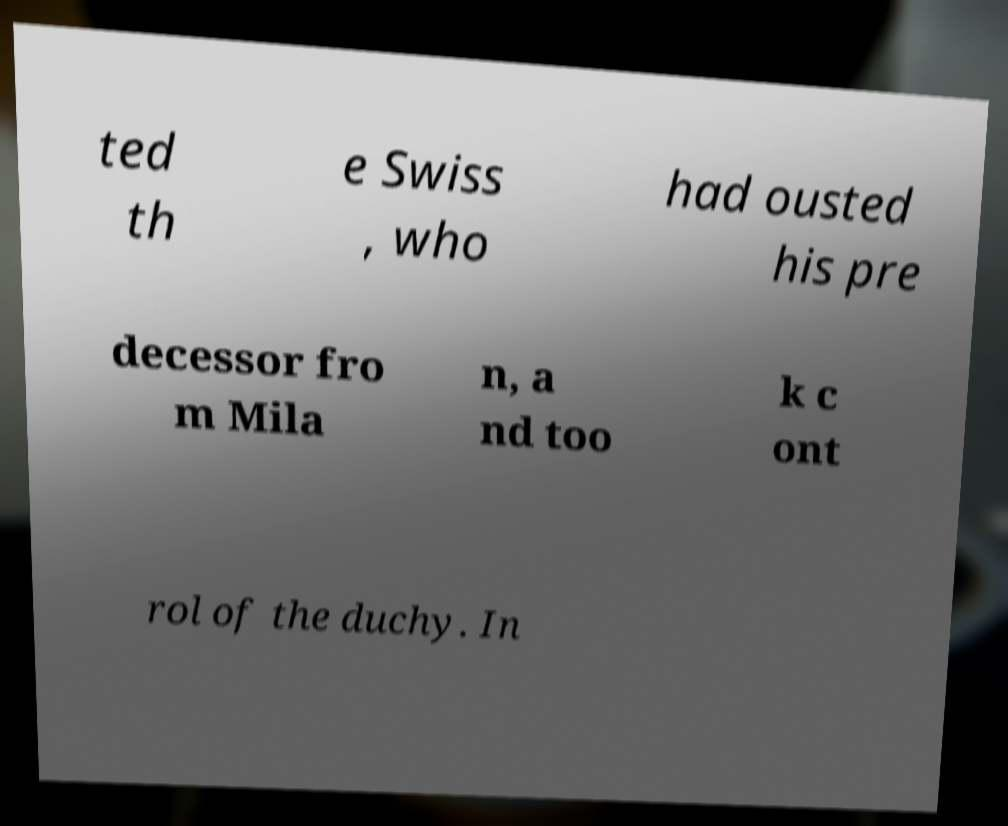Please read and relay the text visible in this image. What does it say? ted th e Swiss , who had ousted his pre decessor fro m Mila n, a nd too k c ont rol of the duchy. In 